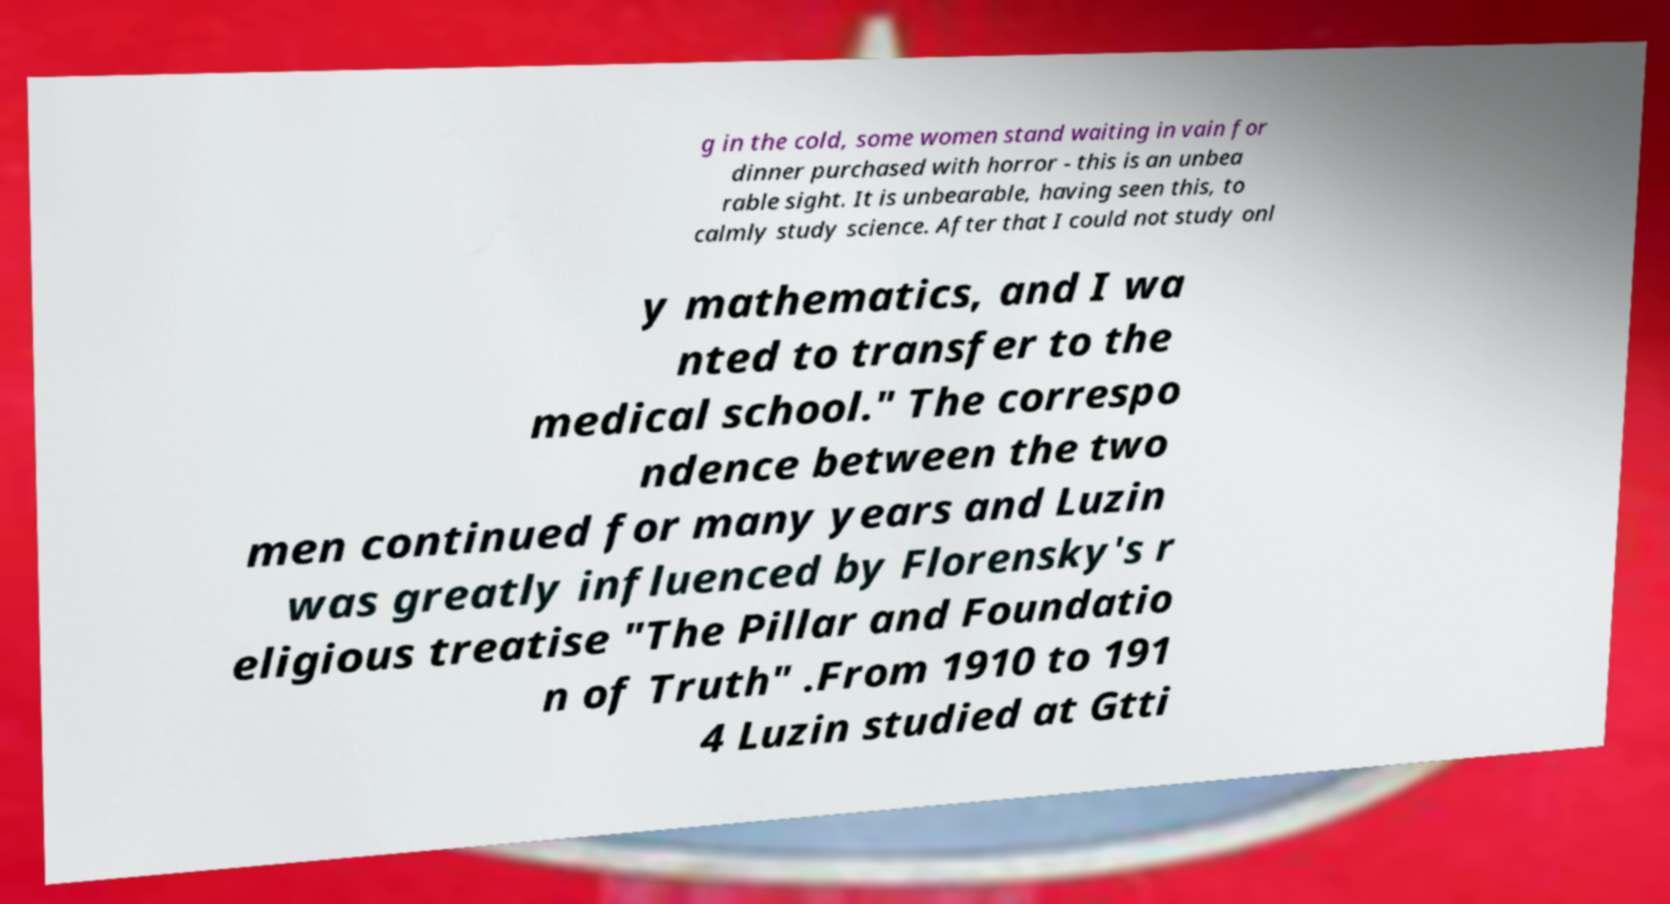Can you accurately transcribe the text from the provided image for me? g in the cold, some women stand waiting in vain for dinner purchased with horror - this is an unbea rable sight. It is unbearable, having seen this, to calmly study science. After that I could not study onl y mathematics, and I wa nted to transfer to the medical school." The correspo ndence between the two men continued for many years and Luzin was greatly influenced by Florensky's r eligious treatise "The Pillar and Foundatio n of Truth" .From 1910 to 191 4 Luzin studied at Gtti 